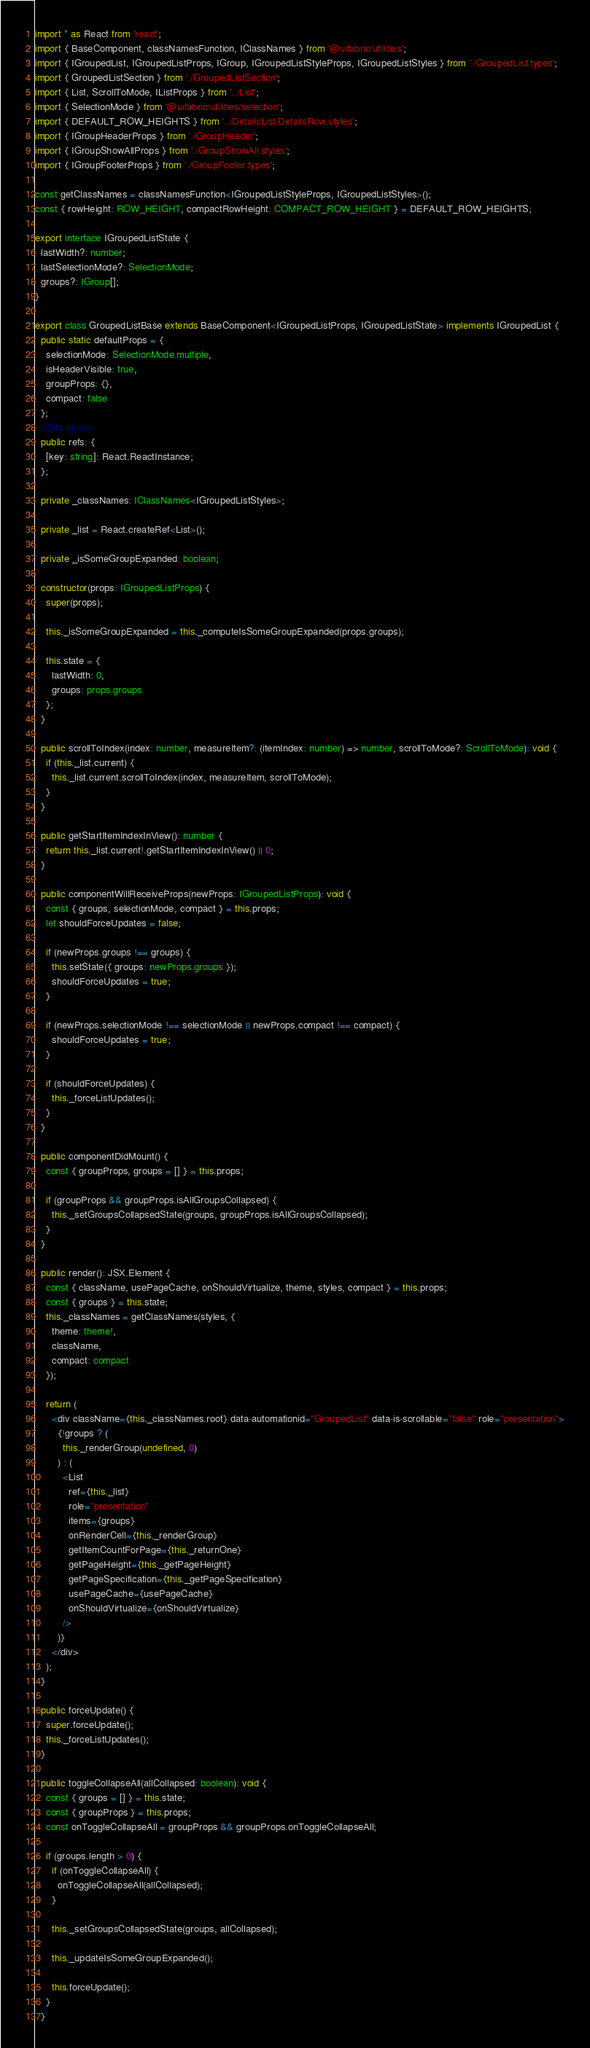Convert code to text. <code><loc_0><loc_0><loc_500><loc_500><_TypeScript_>import * as React from 'react';
import { BaseComponent, classNamesFunction, IClassNames } from '@uifabric/utilities';
import { IGroupedList, IGroupedListProps, IGroup, IGroupedListStyleProps, IGroupedListStyles } from './GroupedList.types';
import { GroupedListSection } from './GroupedListSection';
import { List, ScrollToMode, IListProps } from '../List';
import { SelectionMode } from '@uifabric/utilities/selection';
import { DEFAULT_ROW_HEIGHTS } from '../DetailsList/DetailsRow.styles';
import { IGroupHeaderProps } from './GroupHeader';
import { IGroupShowAllProps } from './GroupShowAll.styles';
import { IGroupFooterProps } from './GroupFooter.types';

const getClassNames = classNamesFunction<IGroupedListStyleProps, IGroupedListStyles>();
const { rowHeight: ROW_HEIGHT, compactRowHeight: COMPACT_ROW_HEIGHT } = DEFAULT_ROW_HEIGHTS;

export interface IGroupedListState {
  lastWidth?: number;
  lastSelectionMode?: SelectionMode;
  groups?: IGroup[];
}

export class GroupedListBase extends BaseComponent<IGroupedListProps, IGroupedListState> implements IGroupedList {
  public static defaultProps = {
    selectionMode: SelectionMode.multiple,
    isHeaderVisible: true,
    groupProps: {},
    compact: false
  };
  //@ts-ignore
  public refs: {
    [key: string]: React.ReactInstance;
  };

  private _classNames: IClassNames<IGroupedListStyles>;

  private _list = React.createRef<List>();

  private _isSomeGroupExpanded: boolean;

  constructor(props: IGroupedListProps) {
    super(props);

    this._isSomeGroupExpanded = this._computeIsSomeGroupExpanded(props.groups);

    this.state = {
      lastWidth: 0,
      groups: props.groups
    };
  }

  public scrollToIndex(index: number, measureItem?: (itemIndex: number) => number, scrollToMode?: ScrollToMode): void {
    if (this._list.current) {
      this._list.current.scrollToIndex(index, measureItem, scrollToMode);
    }
  }

  public getStartItemIndexInView(): number {
    return this._list.current!.getStartItemIndexInView() || 0;
  }

  public componentWillReceiveProps(newProps: IGroupedListProps): void {
    const { groups, selectionMode, compact } = this.props;
    let shouldForceUpdates = false;

    if (newProps.groups !== groups) {
      this.setState({ groups: newProps.groups });
      shouldForceUpdates = true;
    }

    if (newProps.selectionMode !== selectionMode || newProps.compact !== compact) {
      shouldForceUpdates = true;
    }

    if (shouldForceUpdates) {
      this._forceListUpdates();
    }
  }

  public componentDidMount() {
    const { groupProps, groups = [] } = this.props;

    if (groupProps && groupProps.isAllGroupsCollapsed) {
      this._setGroupsCollapsedState(groups, groupProps.isAllGroupsCollapsed);
    }
  }

  public render(): JSX.Element {
    const { className, usePageCache, onShouldVirtualize, theme, styles, compact } = this.props;
    const { groups } = this.state;
    this._classNames = getClassNames(styles, {
      theme: theme!,
      className,
      compact: compact
    });

    return (
      <div className={this._classNames.root} data-automationid="GroupedList" data-is-scrollable="false" role="presentation">
        {!groups ? (
          this._renderGroup(undefined, 0)
        ) : (
          <List
            ref={this._list}
            role="presentation"
            items={groups}
            onRenderCell={this._renderGroup}
            getItemCountForPage={this._returnOne}
            getPageHeight={this._getPageHeight}
            getPageSpecification={this._getPageSpecification}
            usePageCache={usePageCache}
            onShouldVirtualize={onShouldVirtualize}
          />
        )}
      </div>
    );
  }

  public forceUpdate() {
    super.forceUpdate();
    this._forceListUpdates();
  }

  public toggleCollapseAll(allCollapsed: boolean): void {
    const { groups = [] } = this.state;
    const { groupProps } = this.props;
    const onToggleCollapseAll = groupProps && groupProps.onToggleCollapseAll;

    if (groups.length > 0) {
      if (onToggleCollapseAll) {
        onToggleCollapseAll(allCollapsed);
      }

      this._setGroupsCollapsedState(groups, allCollapsed);

      this._updateIsSomeGroupExpanded();

      this.forceUpdate();
    }
  }
</code> 